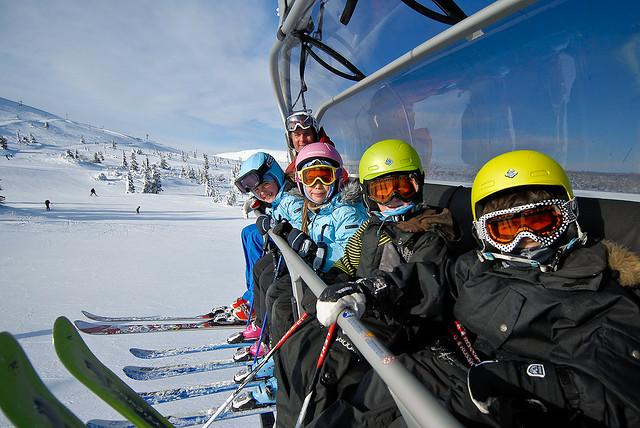Which course are the people on the lift probably being brought to? ski slope 